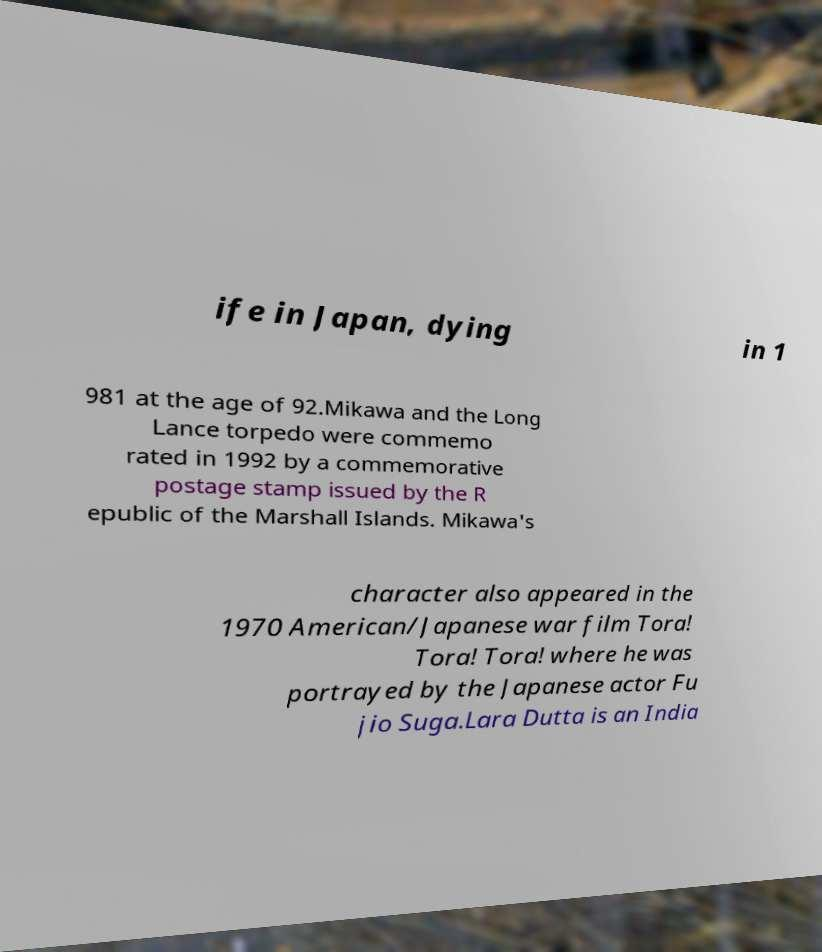Could you assist in decoding the text presented in this image and type it out clearly? ife in Japan, dying in 1 981 at the age of 92.Mikawa and the Long Lance torpedo were commemo rated in 1992 by a commemorative postage stamp issued by the R epublic of the Marshall Islands. Mikawa's character also appeared in the 1970 American/Japanese war film Tora! Tora! Tora! where he was portrayed by the Japanese actor Fu jio Suga.Lara Dutta is an India 